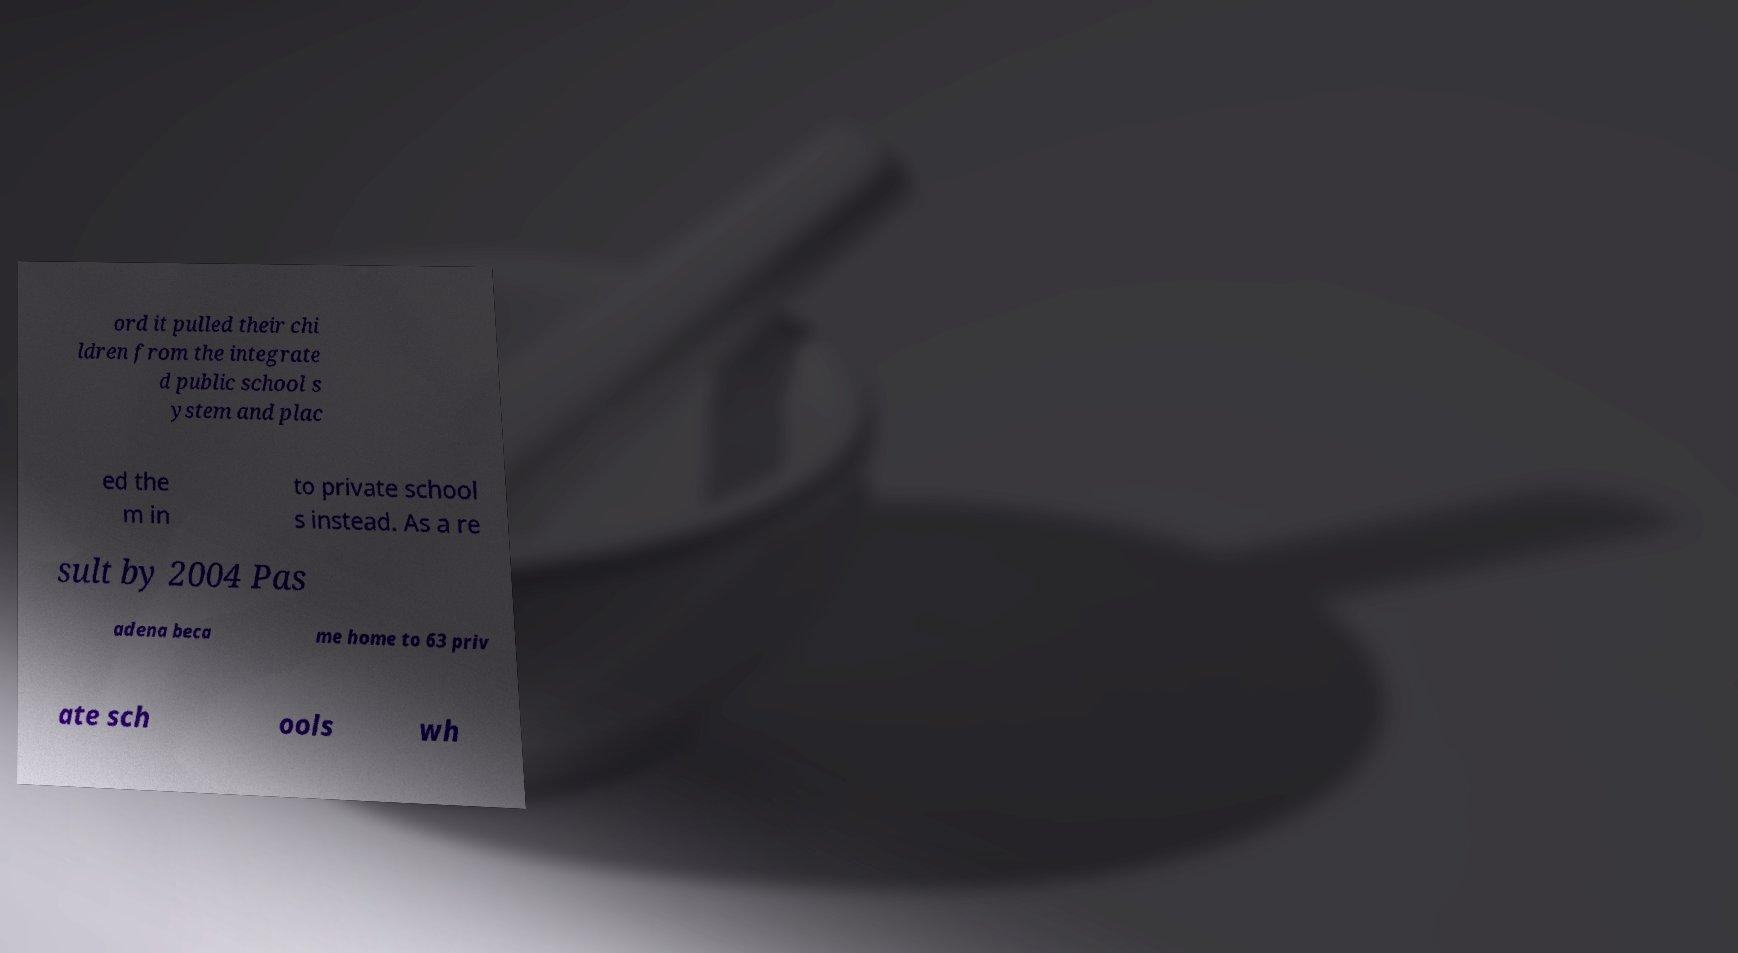There's text embedded in this image that I need extracted. Can you transcribe it verbatim? ord it pulled their chi ldren from the integrate d public school s ystem and plac ed the m in to private school s instead. As a re sult by 2004 Pas adena beca me home to 63 priv ate sch ools wh 